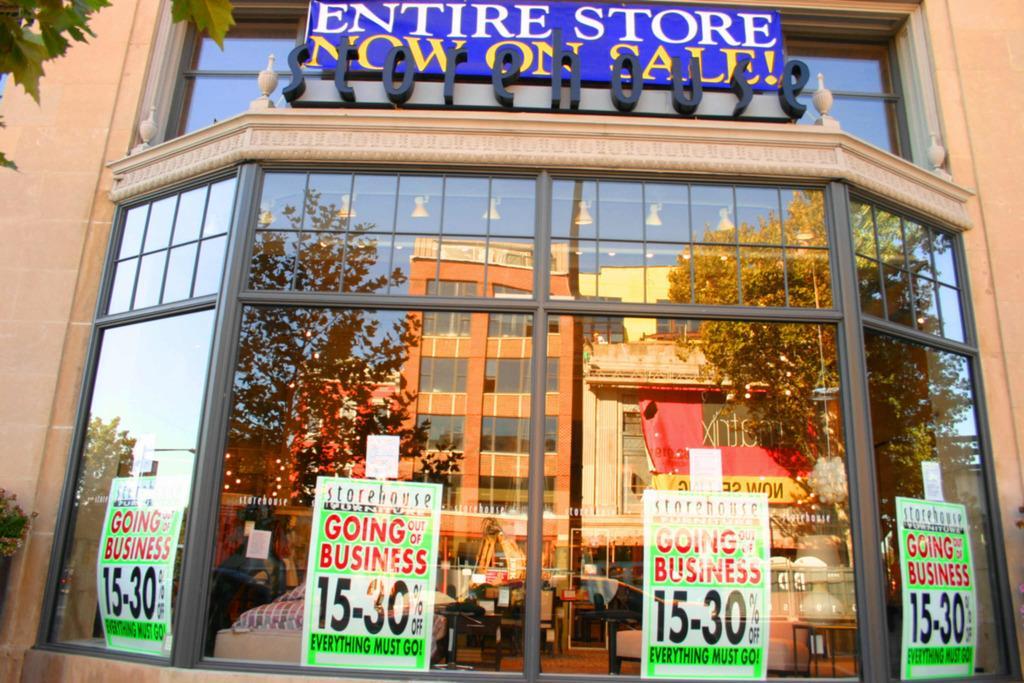Can you describe this image briefly? In this image there is a building for that building there are glass doors, on that doors there are posters, on that posters there is some text and there are trees, buildings are visible, in the top left there are leaves. 